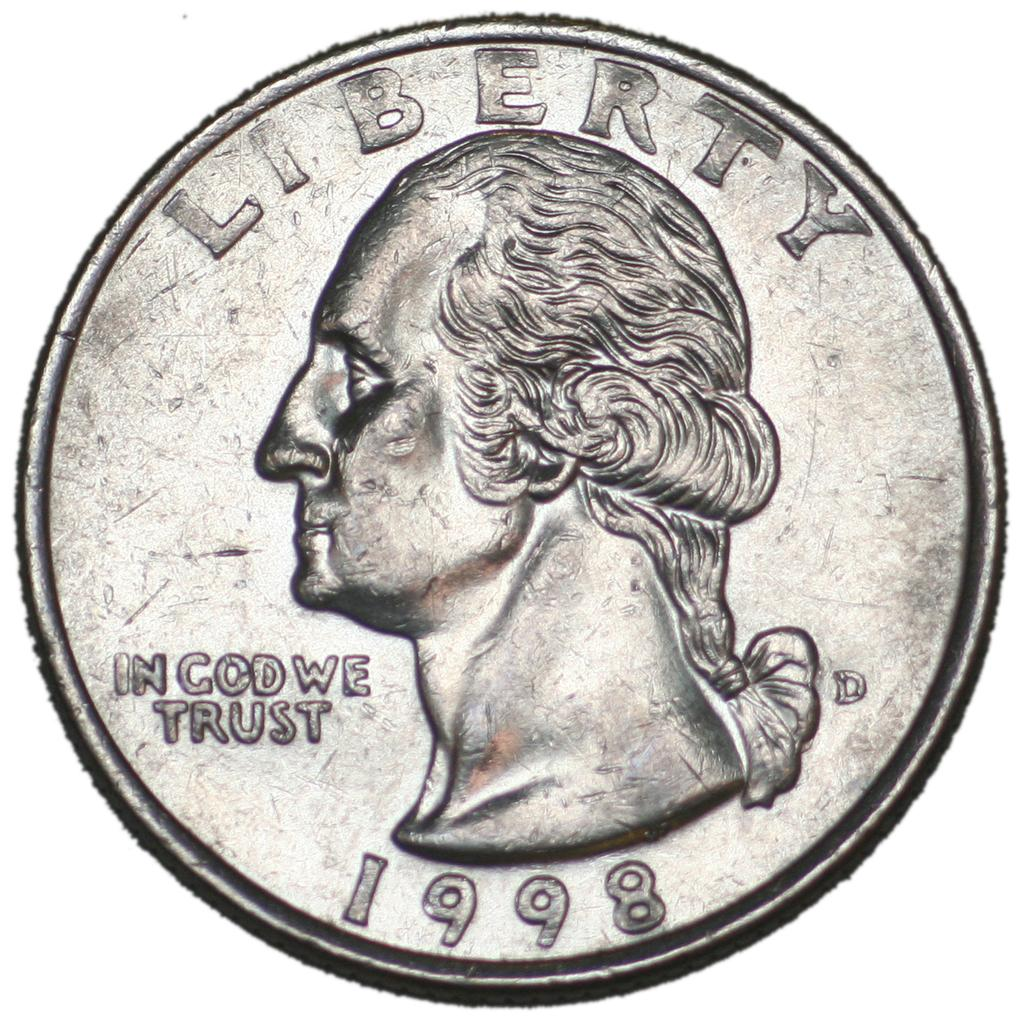What object can be seen in the image? There is a coin in the image. How many rabbits are hopping around the coin in the image? There are no rabbits present in the image; it only features a coin. What type of team is visible in the image? There is no team present in the image; it only features a coin. 